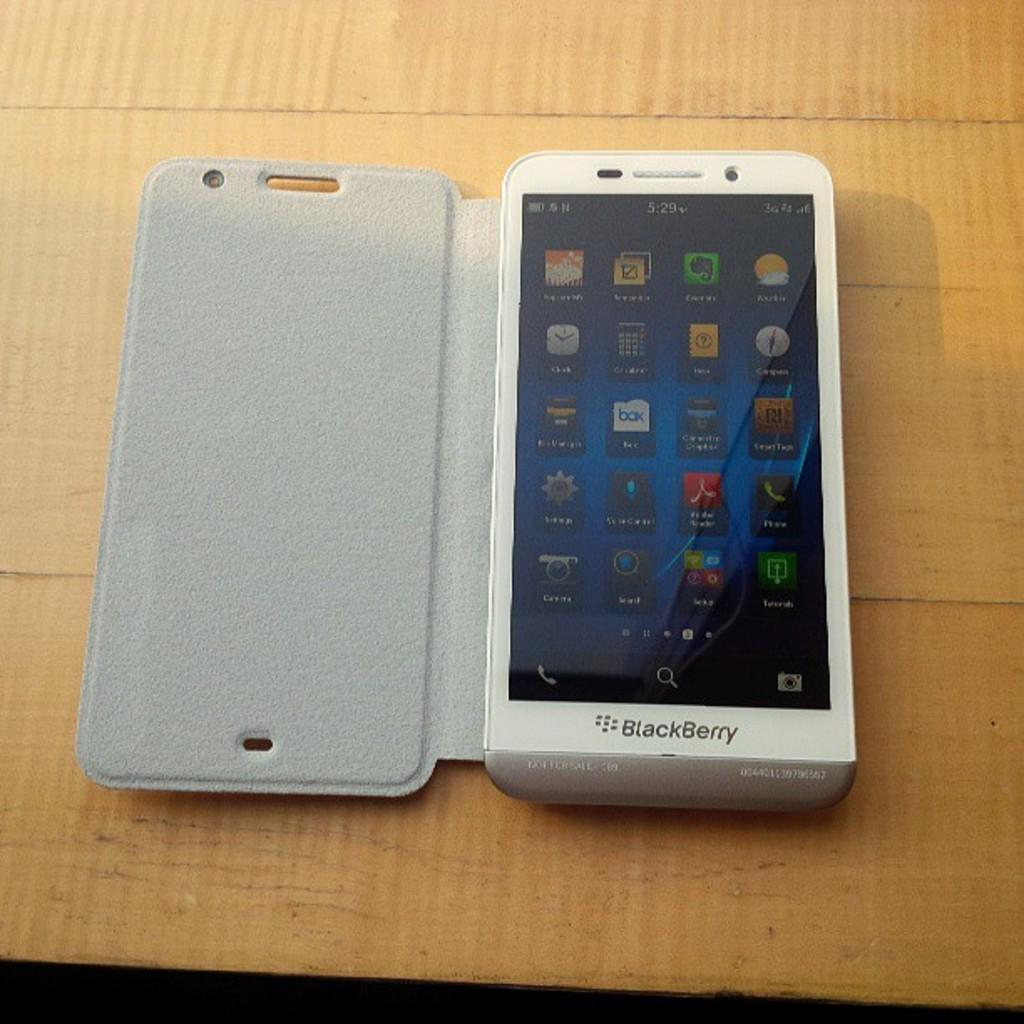Provide a one-sentence caption for the provided image. An unusually thick Blackberry device is displayed open upon a wooden table. 